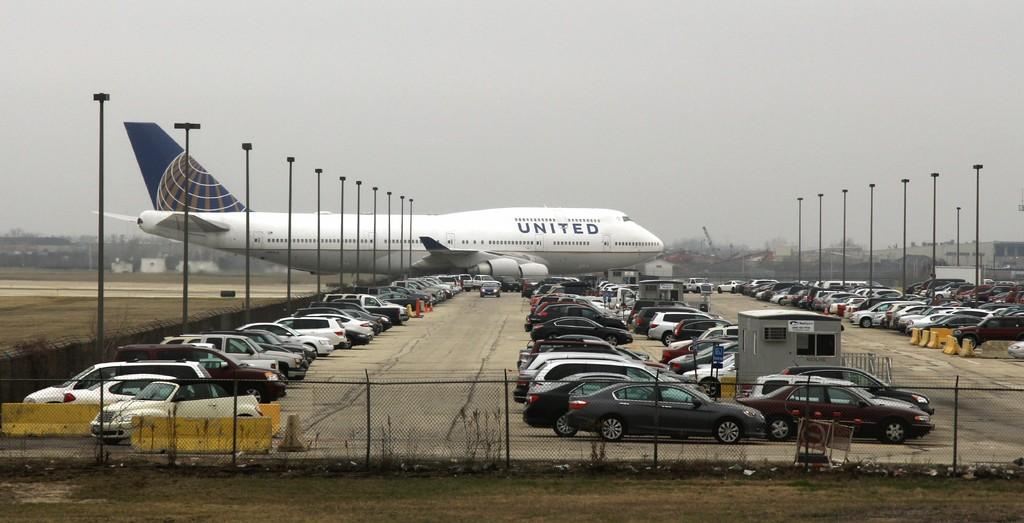<image>
Offer a succinct explanation of the picture presented. a white plane with united written on the side of it 